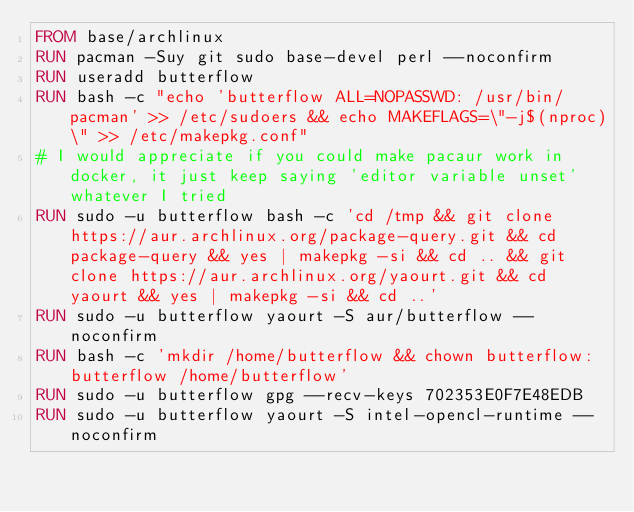Convert code to text. <code><loc_0><loc_0><loc_500><loc_500><_Dockerfile_>FROM base/archlinux
RUN pacman -Suy git sudo base-devel perl --noconfirm
RUN useradd butterflow
RUN bash -c "echo 'butterflow ALL=NOPASSWD: /usr/bin/pacman' >> /etc/sudoers && echo MAKEFLAGS=\"-j$(nproc)\" >> /etc/makepkg.conf"
# I would appreciate if you could make pacaur work in docker, it just keep saying 'editor variable unset' whatever I tried
RUN sudo -u butterflow bash -c 'cd /tmp && git clone https://aur.archlinux.org/package-query.git && cd package-query && yes | makepkg -si && cd .. && git clone https://aur.archlinux.org/yaourt.git && cd yaourt && yes | makepkg -si && cd ..'
RUN sudo -u butterflow yaourt -S aur/butterflow --noconfirm
RUN bash -c 'mkdir /home/butterflow && chown butterflow:butterflow /home/butterflow'
RUN sudo -u butterflow gpg --recv-keys 702353E0F7E48EDB
RUN sudo -u butterflow yaourt -S intel-opencl-runtime --noconfirm
</code> 